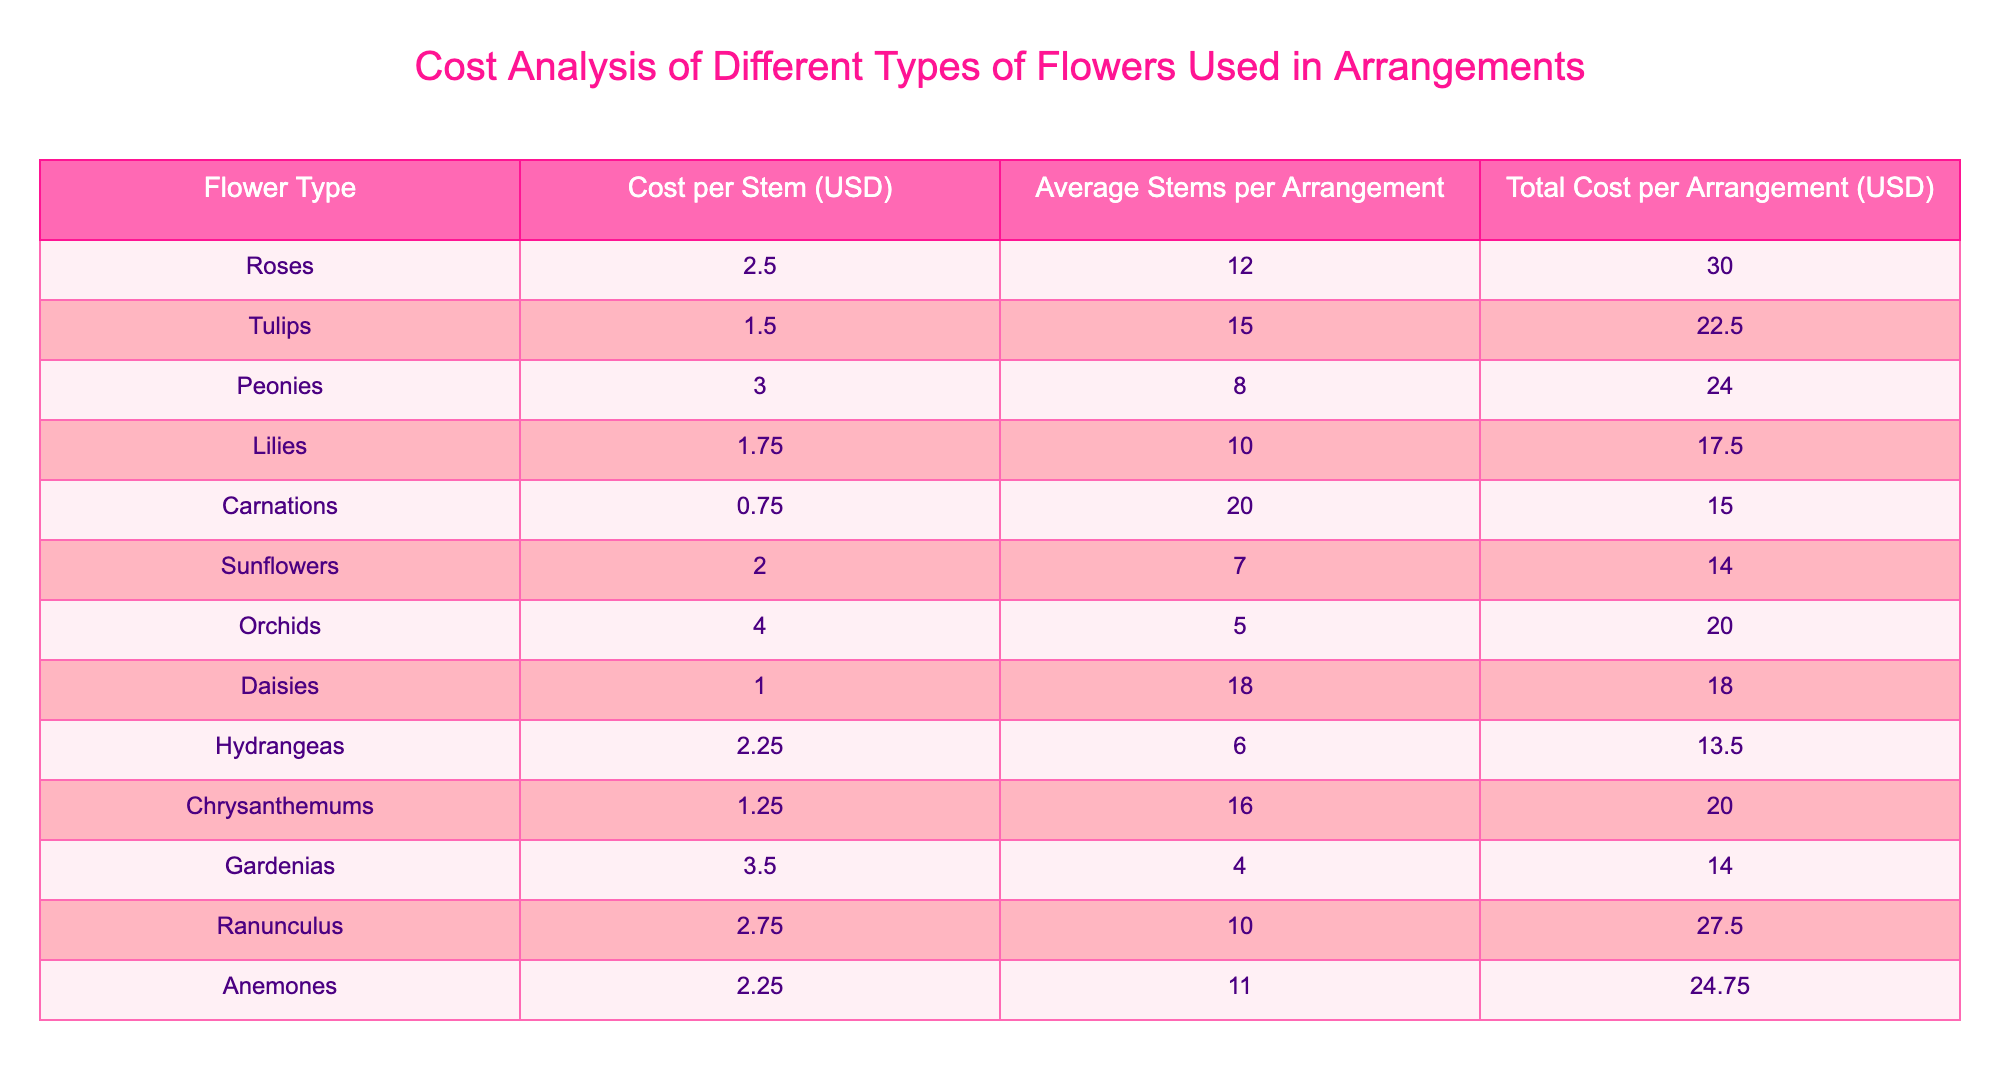What is the cost per stem of orchids? In the table, the cost per stem for orchids is listed directly under the "Cost per Stem (USD)" column. Checking the row for orchids shows that the cost is 4.00 USD.
Answer: 4.00 Which flower type has the highest total cost per arrangement? The total cost per arrangement is found in the "Total Cost per Arrangement (USD)" column. By looking through the values, roses have the highest total cost at 30.00 USD.
Answer: Roses What is the average cost per stem of all flower types? To calculate the average cost, sum up the costs per stem for all flowers: 2.50 + 1.50 + 3.00 + 1.75 + 0.75 + 2.00 + 4.00 + 1.00 + 2.25 + 1.25 + 3.50 + 2.75 + 2.25 = 26.00. There are 13 flower types, thus average = 26.00 / 13 = 2.00.
Answer: 2.00 Does the total cost for lilies exceed that of sunflowers? Looking at the table, the total cost per arrangement for lilies is 17.50 USD, and for sunflowers, it is 14.00 USD. Since 17.50 is greater than 14.00, the statement is true.
Answer: Yes What is the difference in total cost per arrangement between ranunculus and tulips? First, find the total costs: ranunculus is 27.50 USD and tulips are 22.50 USD. Then subtract the two: 27.50 - 22.50 = 5.00. Therefore, the difference is 5.00 USD.
Answer: 5.00 Which flower has the least average stems per arrangement? The average stems per arrangement are given in the "Average Stems per Arrangement" column. By checking each flower, gardenias with 4 stems have the least.
Answer: Gardenias Are there any flowers that have a total cost per arrangement of less than 20 USD? By inspecting the "Total Cost per Arrangement (USD)" column, we can see that carnations (15.00), sunflowers (14.00), and hydrangeas (13.50) all fall below 20.00, which confirms the statement as true.
Answer: Yes How many flowers have a cost per stem of 2.00 USD or more? The relevant entries in the "Cost per Stem (USD)" column that are 2.00 or more are roses (2.50), peonies (3.00), orchids (4.00), and ranunculus (2.75). That makes a total of 6 flower types.
Answer: 6 What is the total cost for a bouquet made with 3 arrangements of chrysanthemums? The total cost for one arrangement of chrysanthemums is 20.00 USD, so for 3 arrangements, we calculate 3 x 20.00 = 60.00 USD.
Answer: 60.00 